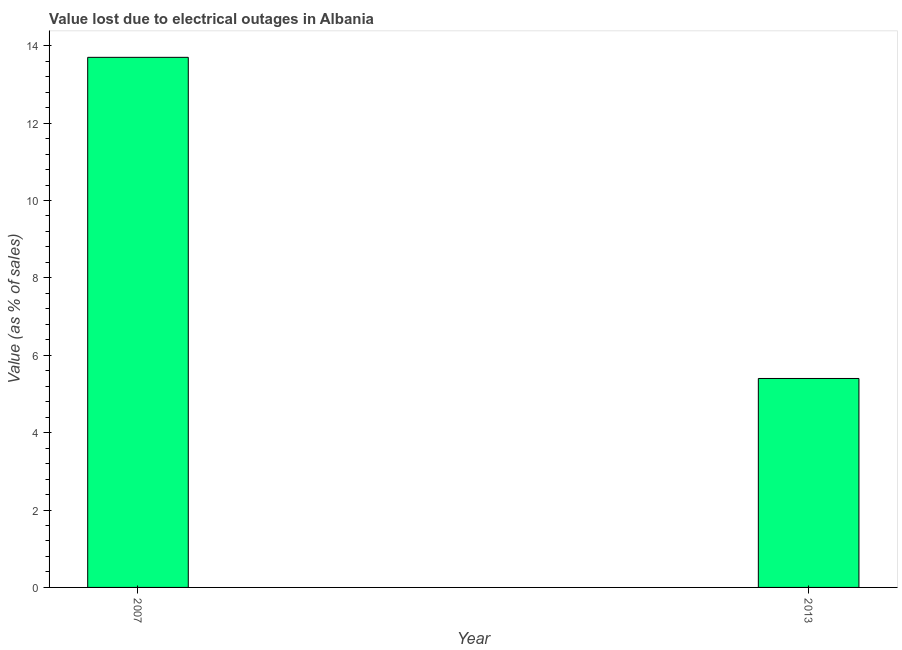Does the graph contain grids?
Make the answer very short. No. What is the title of the graph?
Your answer should be very brief. Value lost due to electrical outages in Albania. What is the label or title of the Y-axis?
Your response must be concise. Value (as % of sales). What is the value lost due to electrical outages in 2007?
Provide a short and direct response. 13.7. Across all years, what is the minimum value lost due to electrical outages?
Your response must be concise. 5.4. In which year was the value lost due to electrical outages minimum?
Your answer should be compact. 2013. What is the difference between the value lost due to electrical outages in 2007 and 2013?
Provide a succinct answer. 8.3. What is the average value lost due to electrical outages per year?
Your answer should be compact. 9.55. What is the median value lost due to electrical outages?
Make the answer very short. 9.55. What is the ratio of the value lost due to electrical outages in 2007 to that in 2013?
Your response must be concise. 2.54. How many bars are there?
Offer a terse response. 2. Are all the bars in the graph horizontal?
Make the answer very short. No. How many years are there in the graph?
Keep it short and to the point. 2. What is the difference between two consecutive major ticks on the Y-axis?
Provide a succinct answer. 2. What is the ratio of the Value (as % of sales) in 2007 to that in 2013?
Your response must be concise. 2.54. 